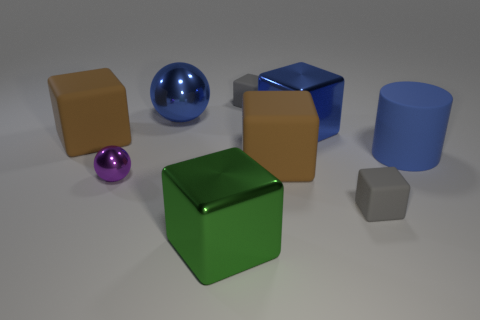Subtract all gray cubes. How many were subtracted if there are1gray cubes left? 1 Subtract 1 blocks. How many blocks are left? 5 Subtract all blue blocks. How many blocks are left? 5 Subtract all large matte blocks. How many blocks are left? 4 Subtract all red blocks. Subtract all blue cylinders. How many blocks are left? 6 Add 1 big brown matte cubes. How many objects exist? 10 Subtract all blocks. How many objects are left? 3 Subtract all large things. Subtract all large blue spheres. How many objects are left? 2 Add 5 big rubber cubes. How many big rubber cubes are left? 7 Add 5 big cyan shiny objects. How many big cyan shiny objects exist? 5 